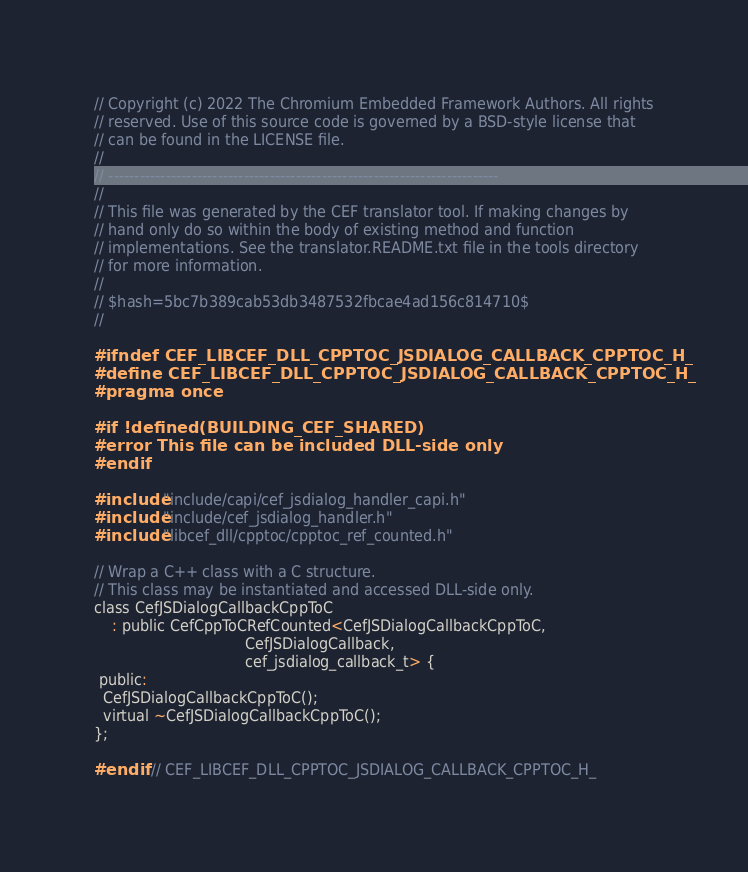Convert code to text. <code><loc_0><loc_0><loc_500><loc_500><_C_>// Copyright (c) 2022 The Chromium Embedded Framework Authors. All rights
// reserved. Use of this source code is governed by a BSD-style license that
// can be found in the LICENSE file.
//
// ---------------------------------------------------------------------------
//
// This file was generated by the CEF translator tool. If making changes by
// hand only do so within the body of existing method and function
// implementations. See the translator.README.txt file in the tools directory
// for more information.
//
// $hash=5bc7b389cab53db3487532fbcae4ad156c814710$
//

#ifndef CEF_LIBCEF_DLL_CPPTOC_JSDIALOG_CALLBACK_CPPTOC_H_
#define CEF_LIBCEF_DLL_CPPTOC_JSDIALOG_CALLBACK_CPPTOC_H_
#pragma once

#if !defined(BUILDING_CEF_SHARED)
#error This file can be included DLL-side only
#endif

#include "include/capi/cef_jsdialog_handler_capi.h"
#include "include/cef_jsdialog_handler.h"
#include "libcef_dll/cpptoc/cpptoc_ref_counted.h"

// Wrap a C++ class with a C structure.
// This class may be instantiated and accessed DLL-side only.
class CefJSDialogCallbackCppToC
    : public CefCppToCRefCounted<CefJSDialogCallbackCppToC,
                                 CefJSDialogCallback,
                                 cef_jsdialog_callback_t> {
 public:
  CefJSDialogCallbackCppToC();
  virtual ~CefJSDialogCallbackCppToC();
};

#endif  // CEF_LIBCEF_DLL_CPPTOC_JSDIALOG_CALLBACK_CPPTOC_H_
</code> 